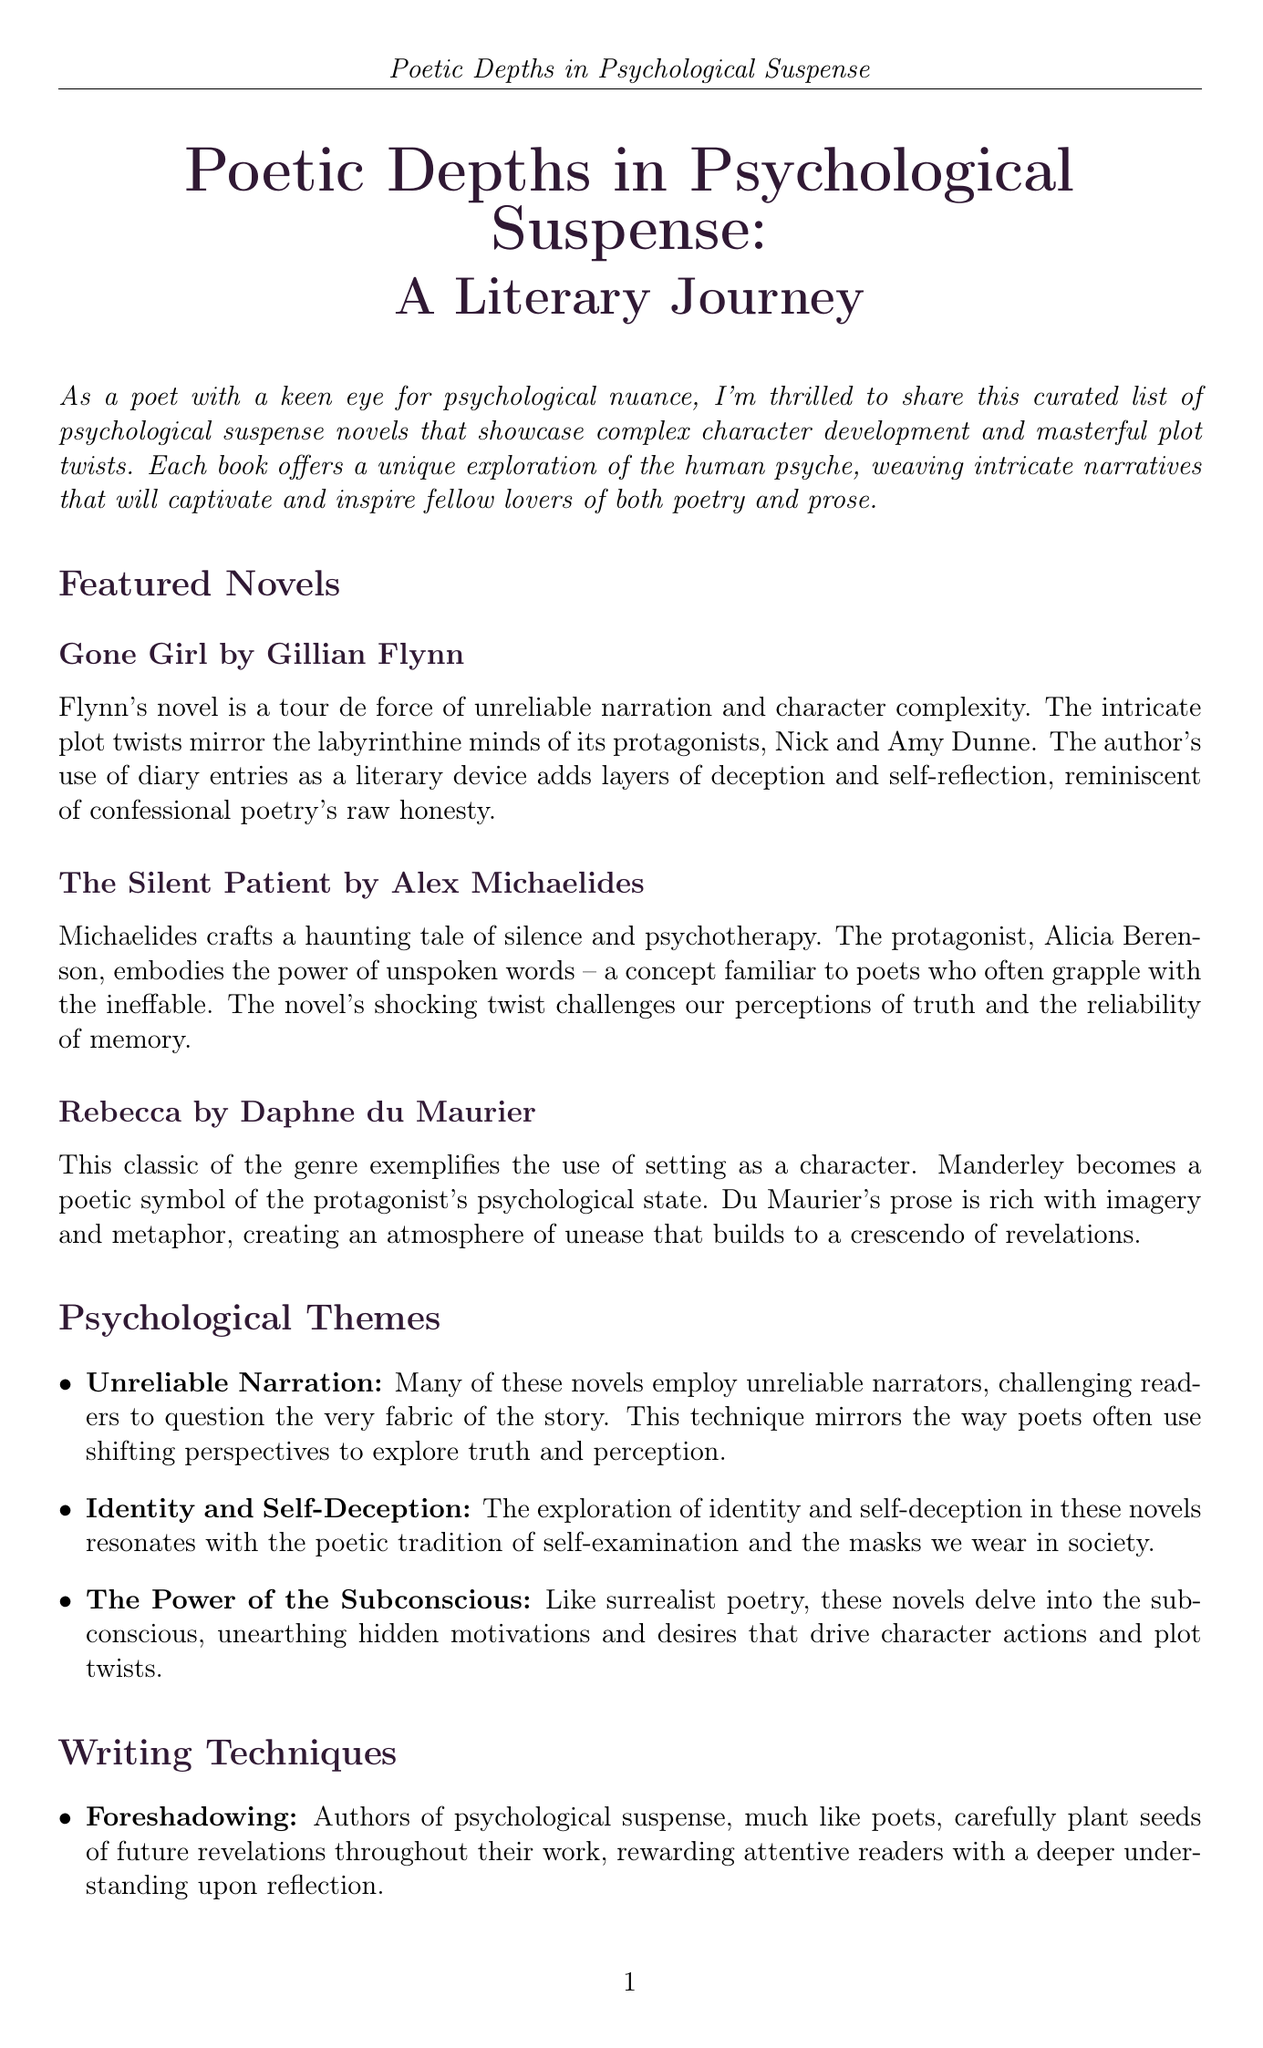What is the title of the newsletter? The title of the newsletter is found in the header and introduction, indicating the focus of the content.
Answer: Poetic Depths in Psychological Suspense: A Literary Journey Who is the author of "Gone Girl"? The author's name is mentioned alongside the title of the book in the featured novels section.
Answer: Gillian Flynn What psychological theme is associated with unreliable narration? The description of this theme highlights its significance in challenging readers' perceptions, reflecting poetic techniques.
Answer: Many of these novels employ unreliable narrators.. What is a technique used in psychological suspense novels? The writing techniques section lists specific techniques used by authors to create suspense.
Answer: Foreshadowing Which novel is recommended as a must-read? The recommendation section specifically identifies the highlighted book for readers this month.
Answer: We Have Always Lived in the Castle What does the protagonist Merricat Blackwood represent? The analysis of the recommended book attributes specific narrative qualities to the protagonist.
Answer: A lyrical cadence that belies the darkness What literary device is used in "Gone Girl"? The analysis of the book discusses specific approaches the author employs to enhance narrative complexity.
Answer: Diary entries Who is the author of "The Silent Patient"? The author's name is provided directly below the title of the book in the featured novels section.
Answer: Alex Michaelides How does the newsletter describe the setting in "Rebecca"? The analysis section for "Rebecca" explains the role of setting in relation to the protagonist's psyche.
Answer: A poetic symbol of the protagonist's psychological state 